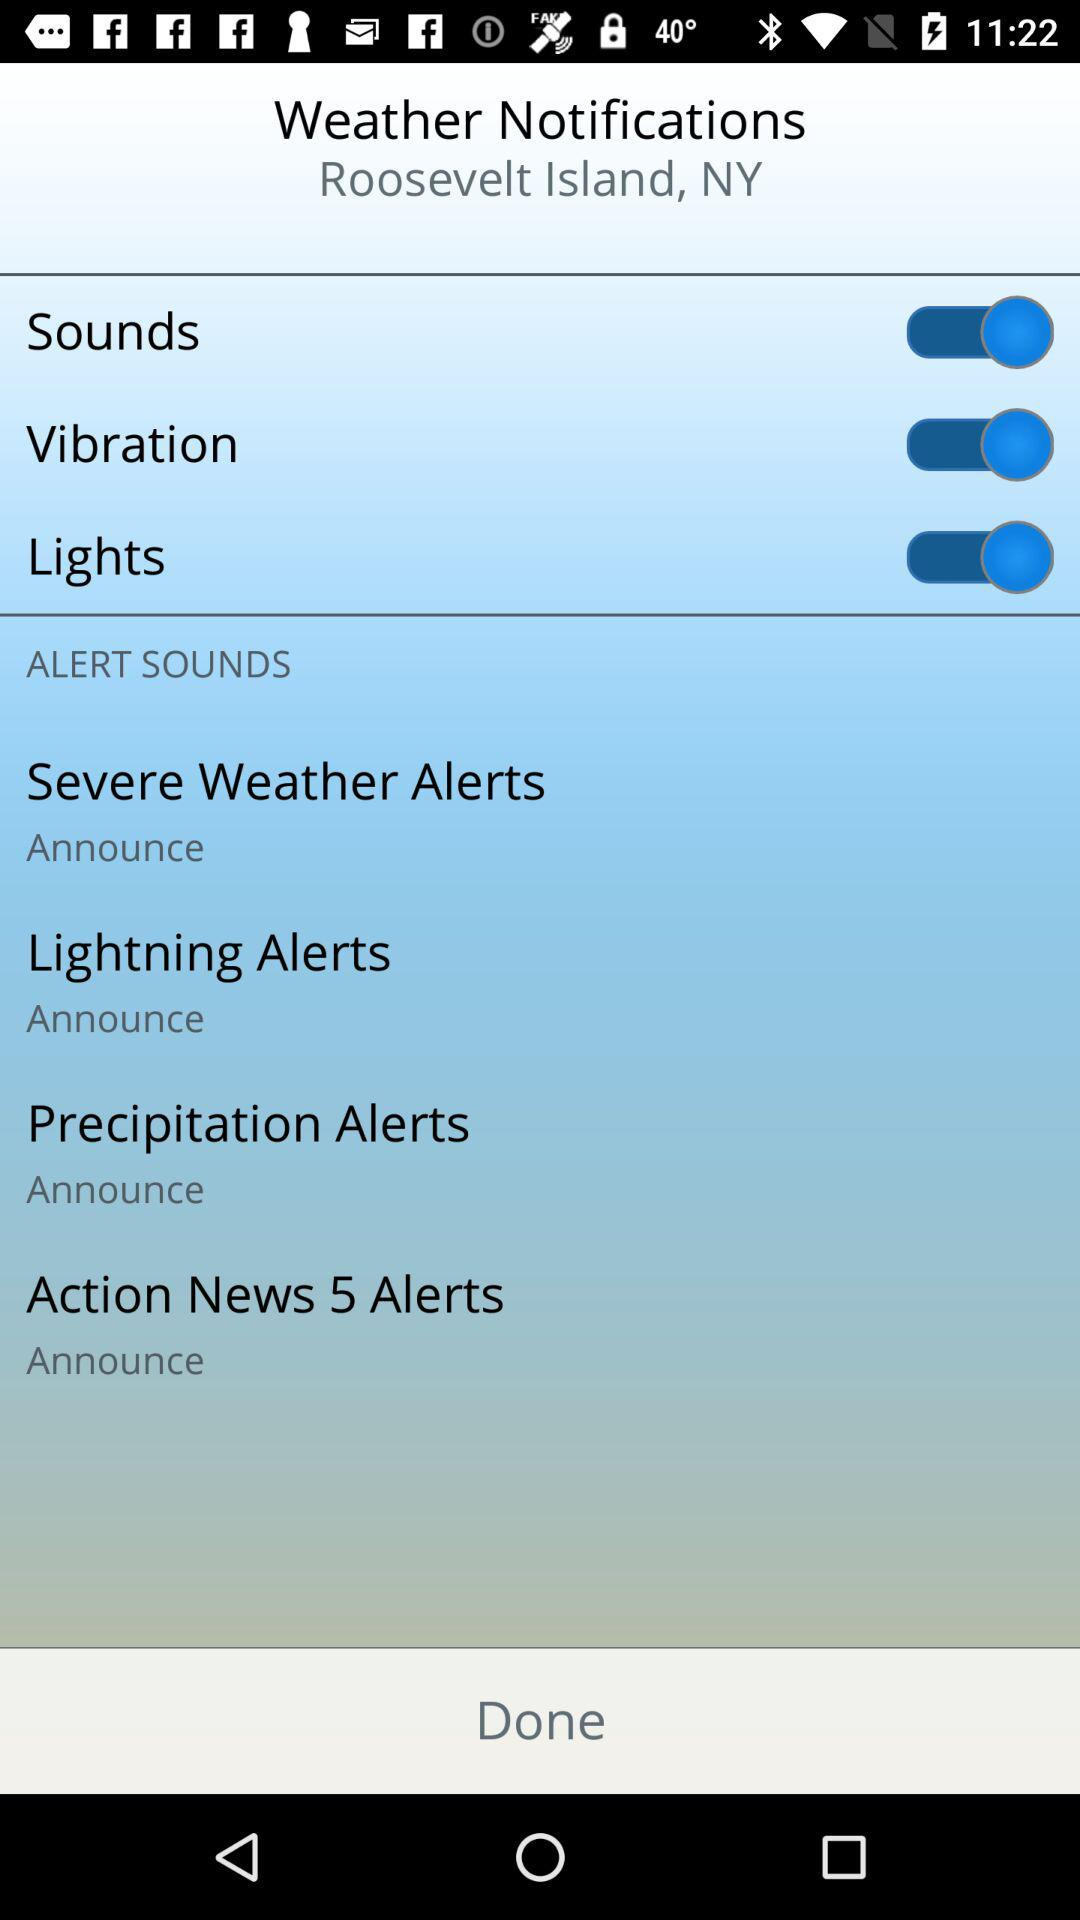What is the setting for lightning alerts? The setting for lightning alerts is "Announce". 